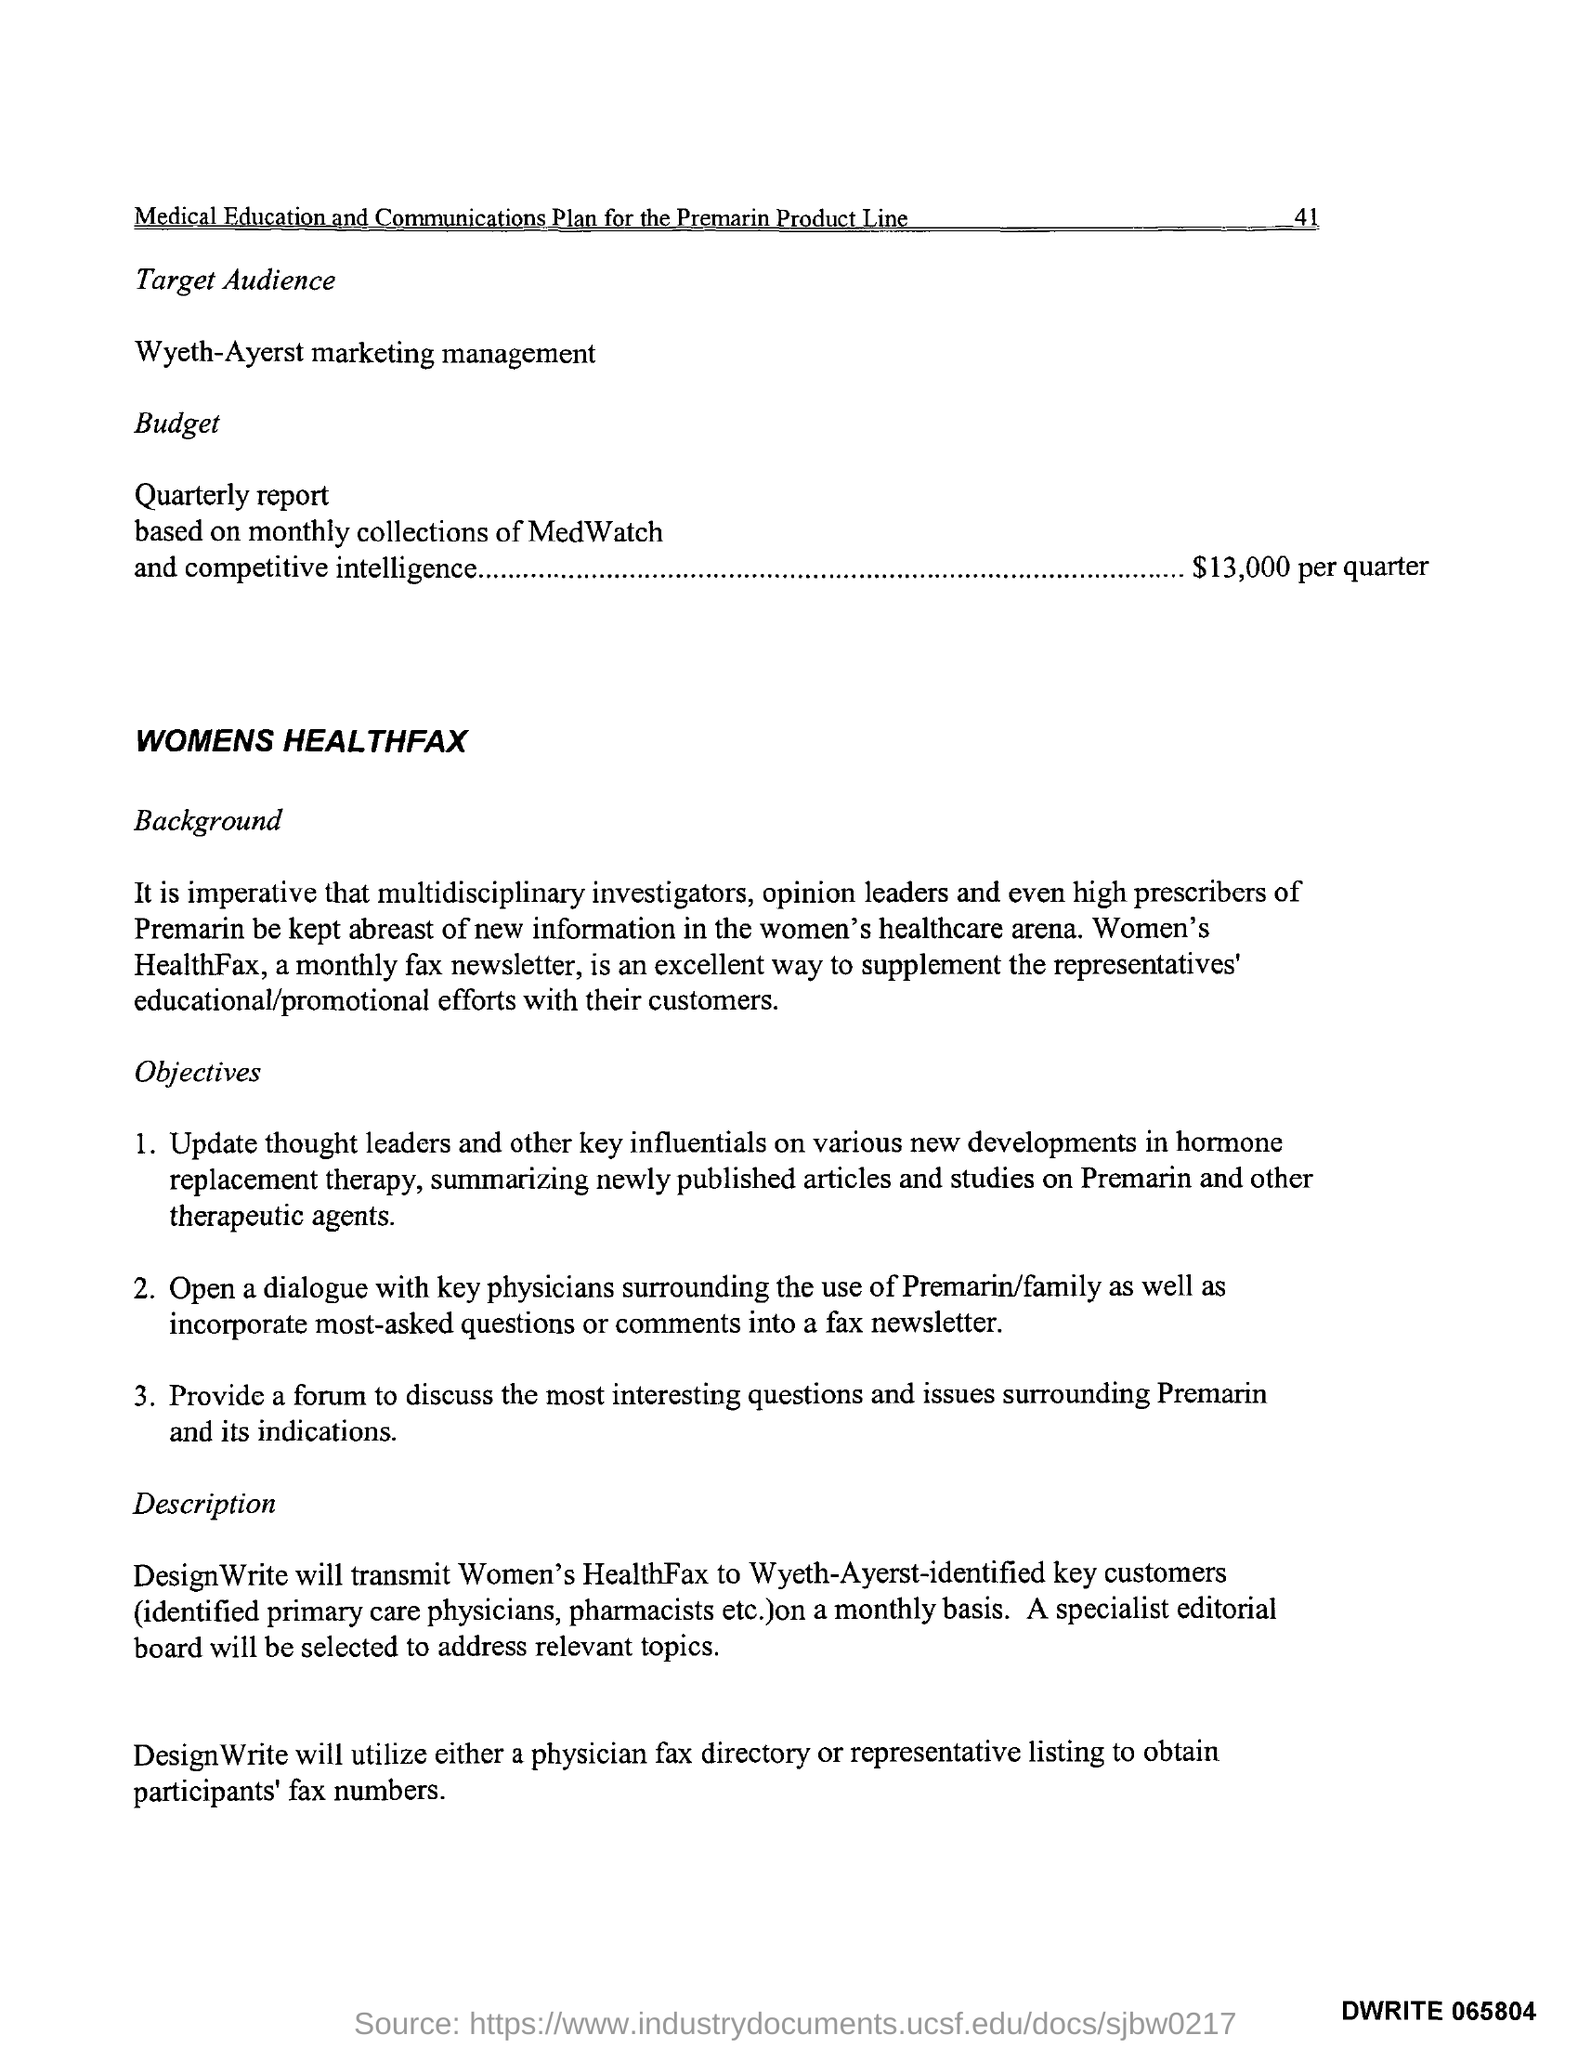What is the name of monthly fax news letter?
Provide a succinct answer. Womens Healthfax. Budget for quarterly report?
Give a very brief answer. $ 13,000 per quarter. 